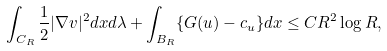Convert formula to latex. <formula><loc_0><loc_0><loc_500><loc_500>\int _ { C _ { R } } \frac { 1 } { 2 } | \nabla v | ^ { 2 } d x d \lambda + \int _ { B _ { R } } \{ G ( u ) - c _ { u } \} d x \leq C R ^ { 2 } \log R ,</formula> 